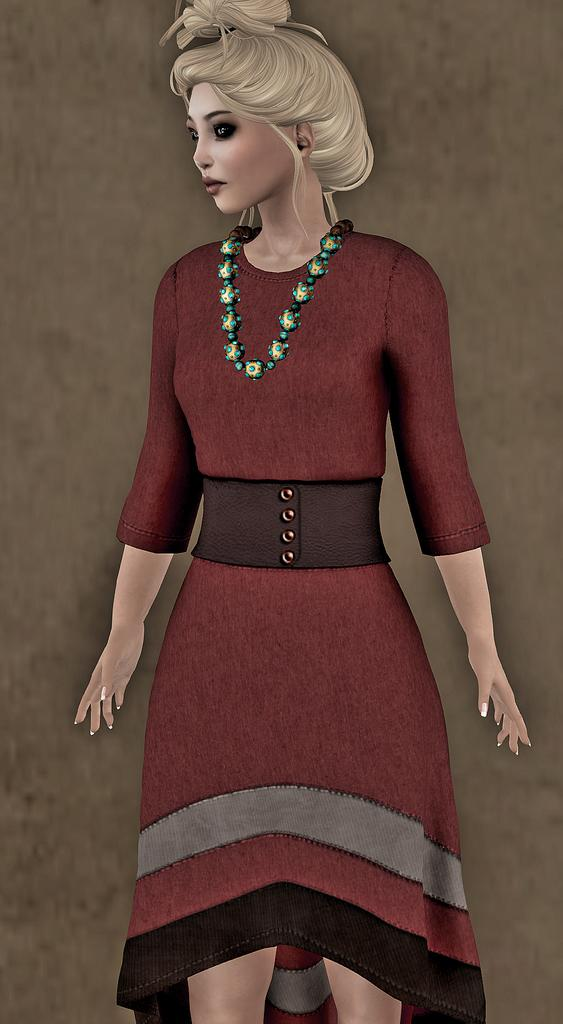What type of media is the image? The image is an animation. Who is present in the image? There is a woman in the image. What is the woman wearing? The woman is wearing a red dress. How is the woman described? The woman is stunning. What color is the background in the image? The background in the image is brown. How many ducks are swimming in the background of the image? There are no ducks present in the image; it is an animation featuring a woman in a red dress with a brown background. What type of lipstick is the woman wearing in the image? The image is an animation, and it does not show the woman wearing lipstick or any makeup. 